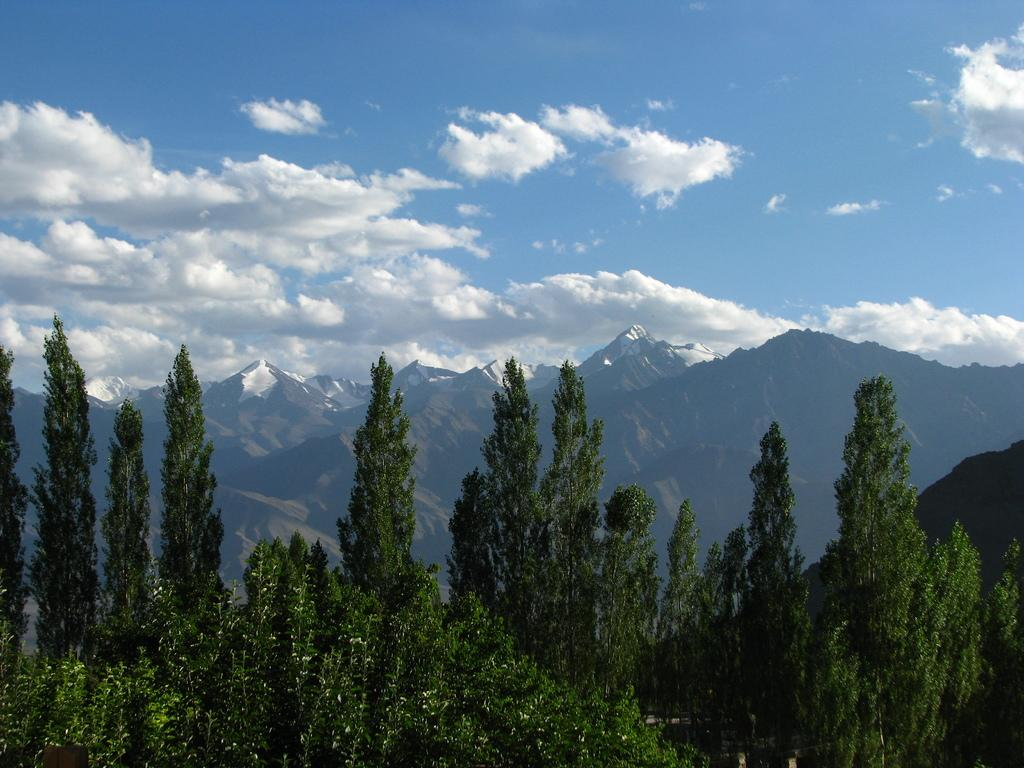What type of vegetation can be seen in the front of the image? There are trees in the front of the image. What type of landscape feature is visible in the background of the image? There are hills visible in the background of the image. What part of the natural environment is visible in the image? The sky is visible in the image. What can be observed in the sky? Clouds are present in the sky. What is the name of the pig in the image? There is no pig present in the image. Does the image convey any sense of regret? The image does not convey any emotions, including regret, as it is a landscape scene without any human or animal subjects. 